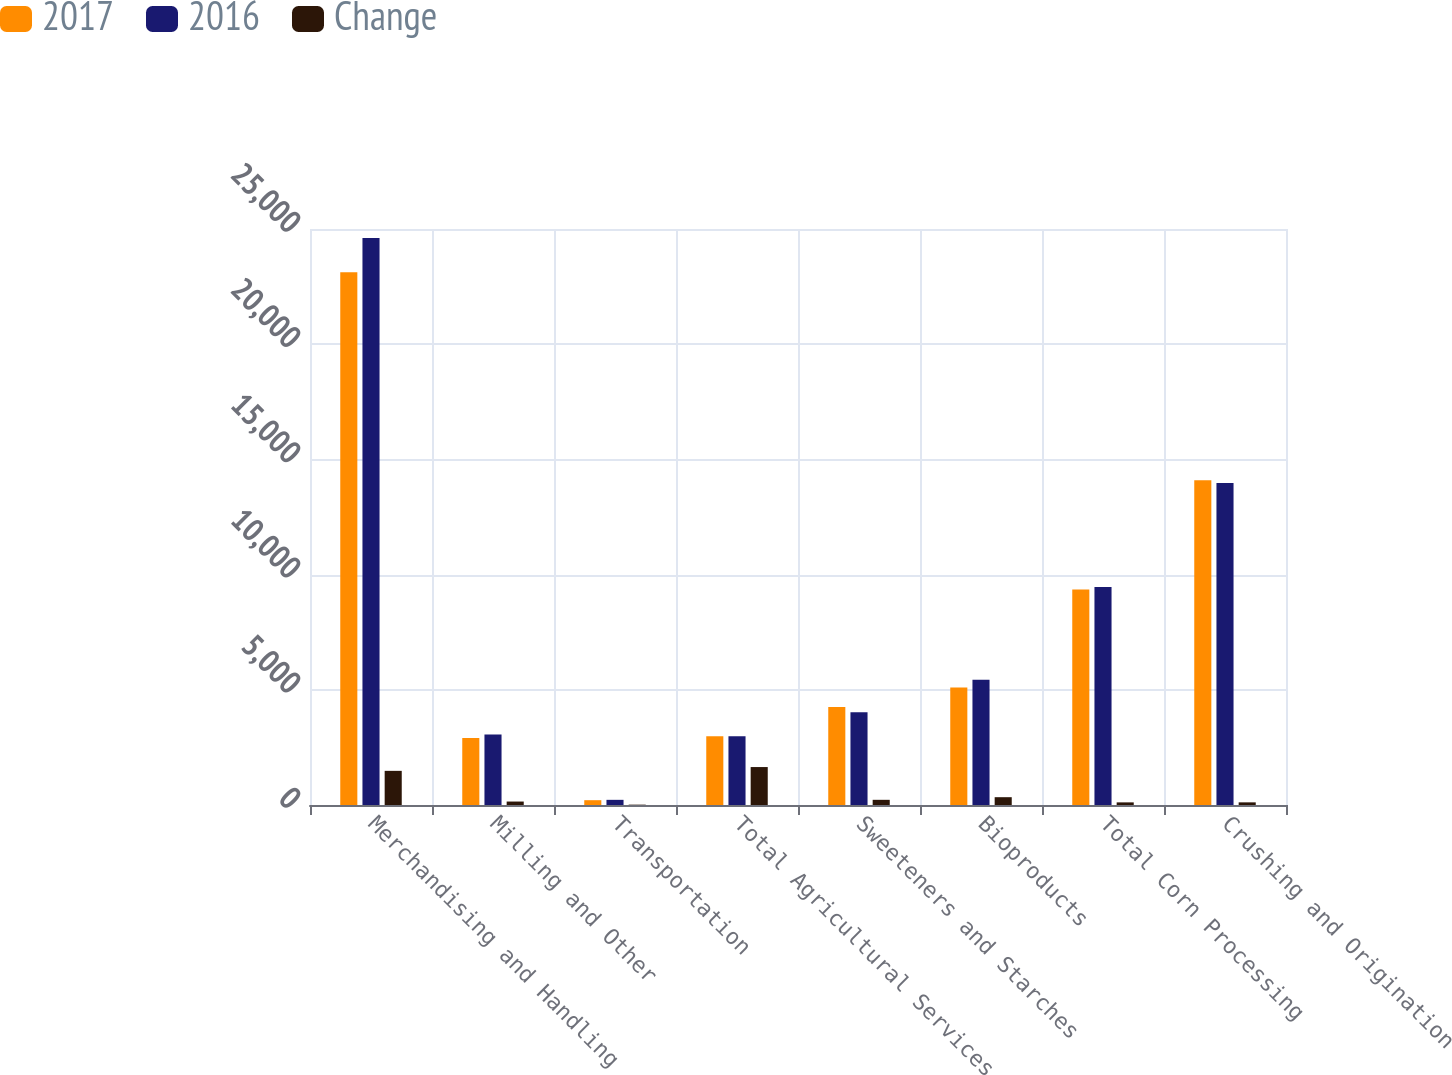Convert chart to OTSL. <chart><loc_0><loc_0><loc_500><loc_500><stacked_bar_chart><ecel><fcel>Merchandising and Handling<fcel>Milling and Other<fcel>Transportation<fcel>Total Agricultural Services<fcel>Sweeteners and Starches<fcel>Bioproducts<fcel>Total Corn Processing<fcel>Crushing and Origination<nl><fcel>2017<fcel>23127<fcel>2910<fcel>209<fcel>2985<fcel>4253<fcel>5099<fcel>9352<fcel>14091<nl><fcel>2016<fcel>24609<fcel>3060<fcel>224<fcel>2985<fcel>4028<fcel>5438<fcel>9466<fcel>13976<nl><fcel>Change<fcel>1482<fcel>150<fcel>15<fcel>1647<fcel>225<fcel>339<fcel>114<fcel>115<nl></chart> 